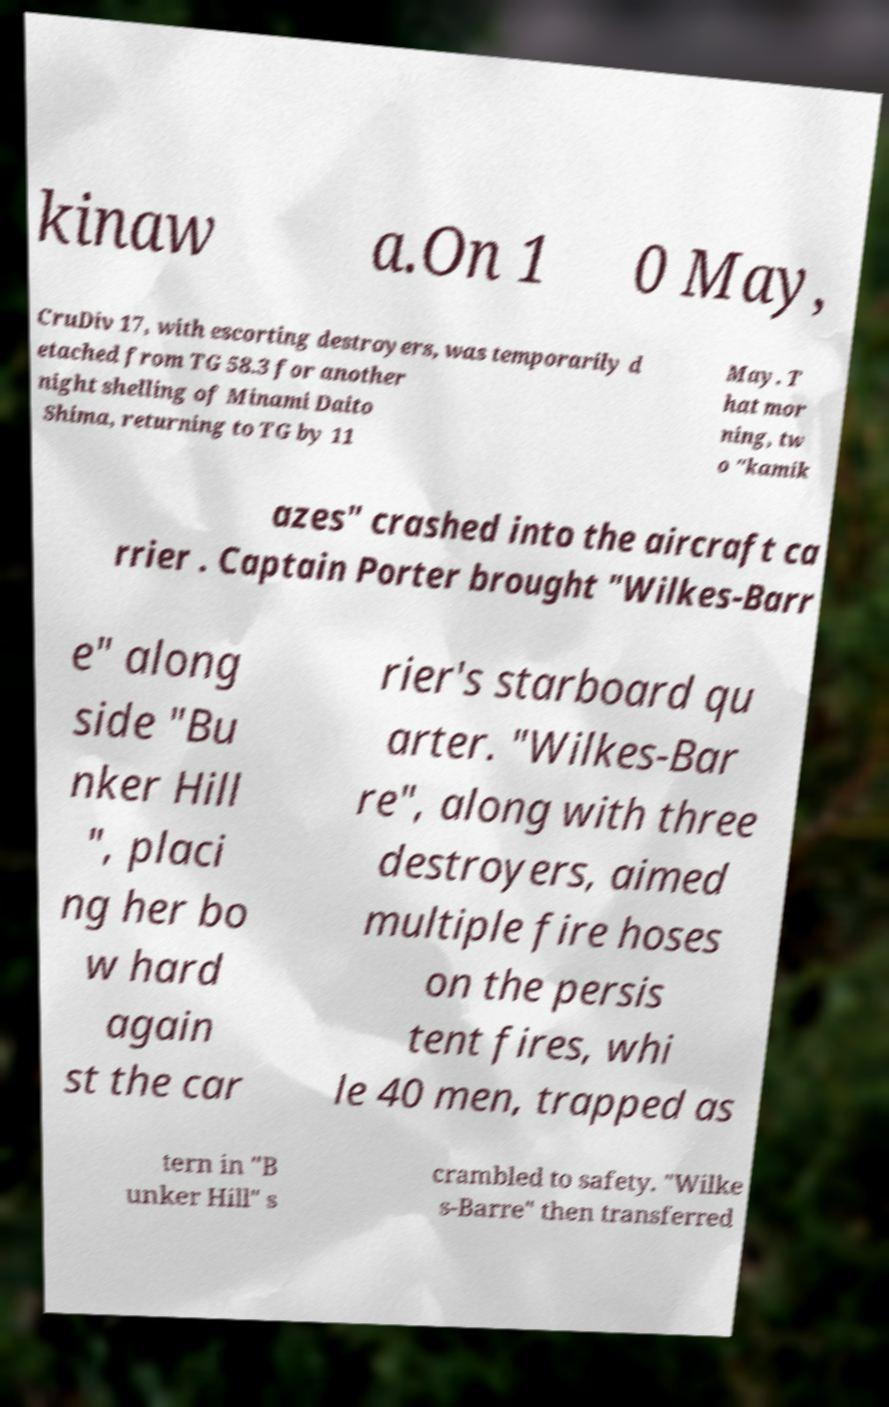Please read and relay the text visible in this image. What does it say? kinaw a.On 1 0 May, CruDiv 17, with escorting destroyers, was temporarily d etached from TG 58.3 for another night shelling of Minami Daito Shima, returning to TG by 11 May. T hat mor ning, tw o "kamik azes" crashed into the aircraft ca rrier . Captain Porter brought "Wilkes-Barr e" along side "Bu nker Hill ", placi ng her bo w hard again st the car rier's starboard qu arter. "Wilkes-Bar re", along with three destroyers, aimed multiple fire hoses on the persis tent fires, whi le 40 men, trapped as tern in "B unker Hill" s crambled to safety. "Wilke s-Barre" then transferred 